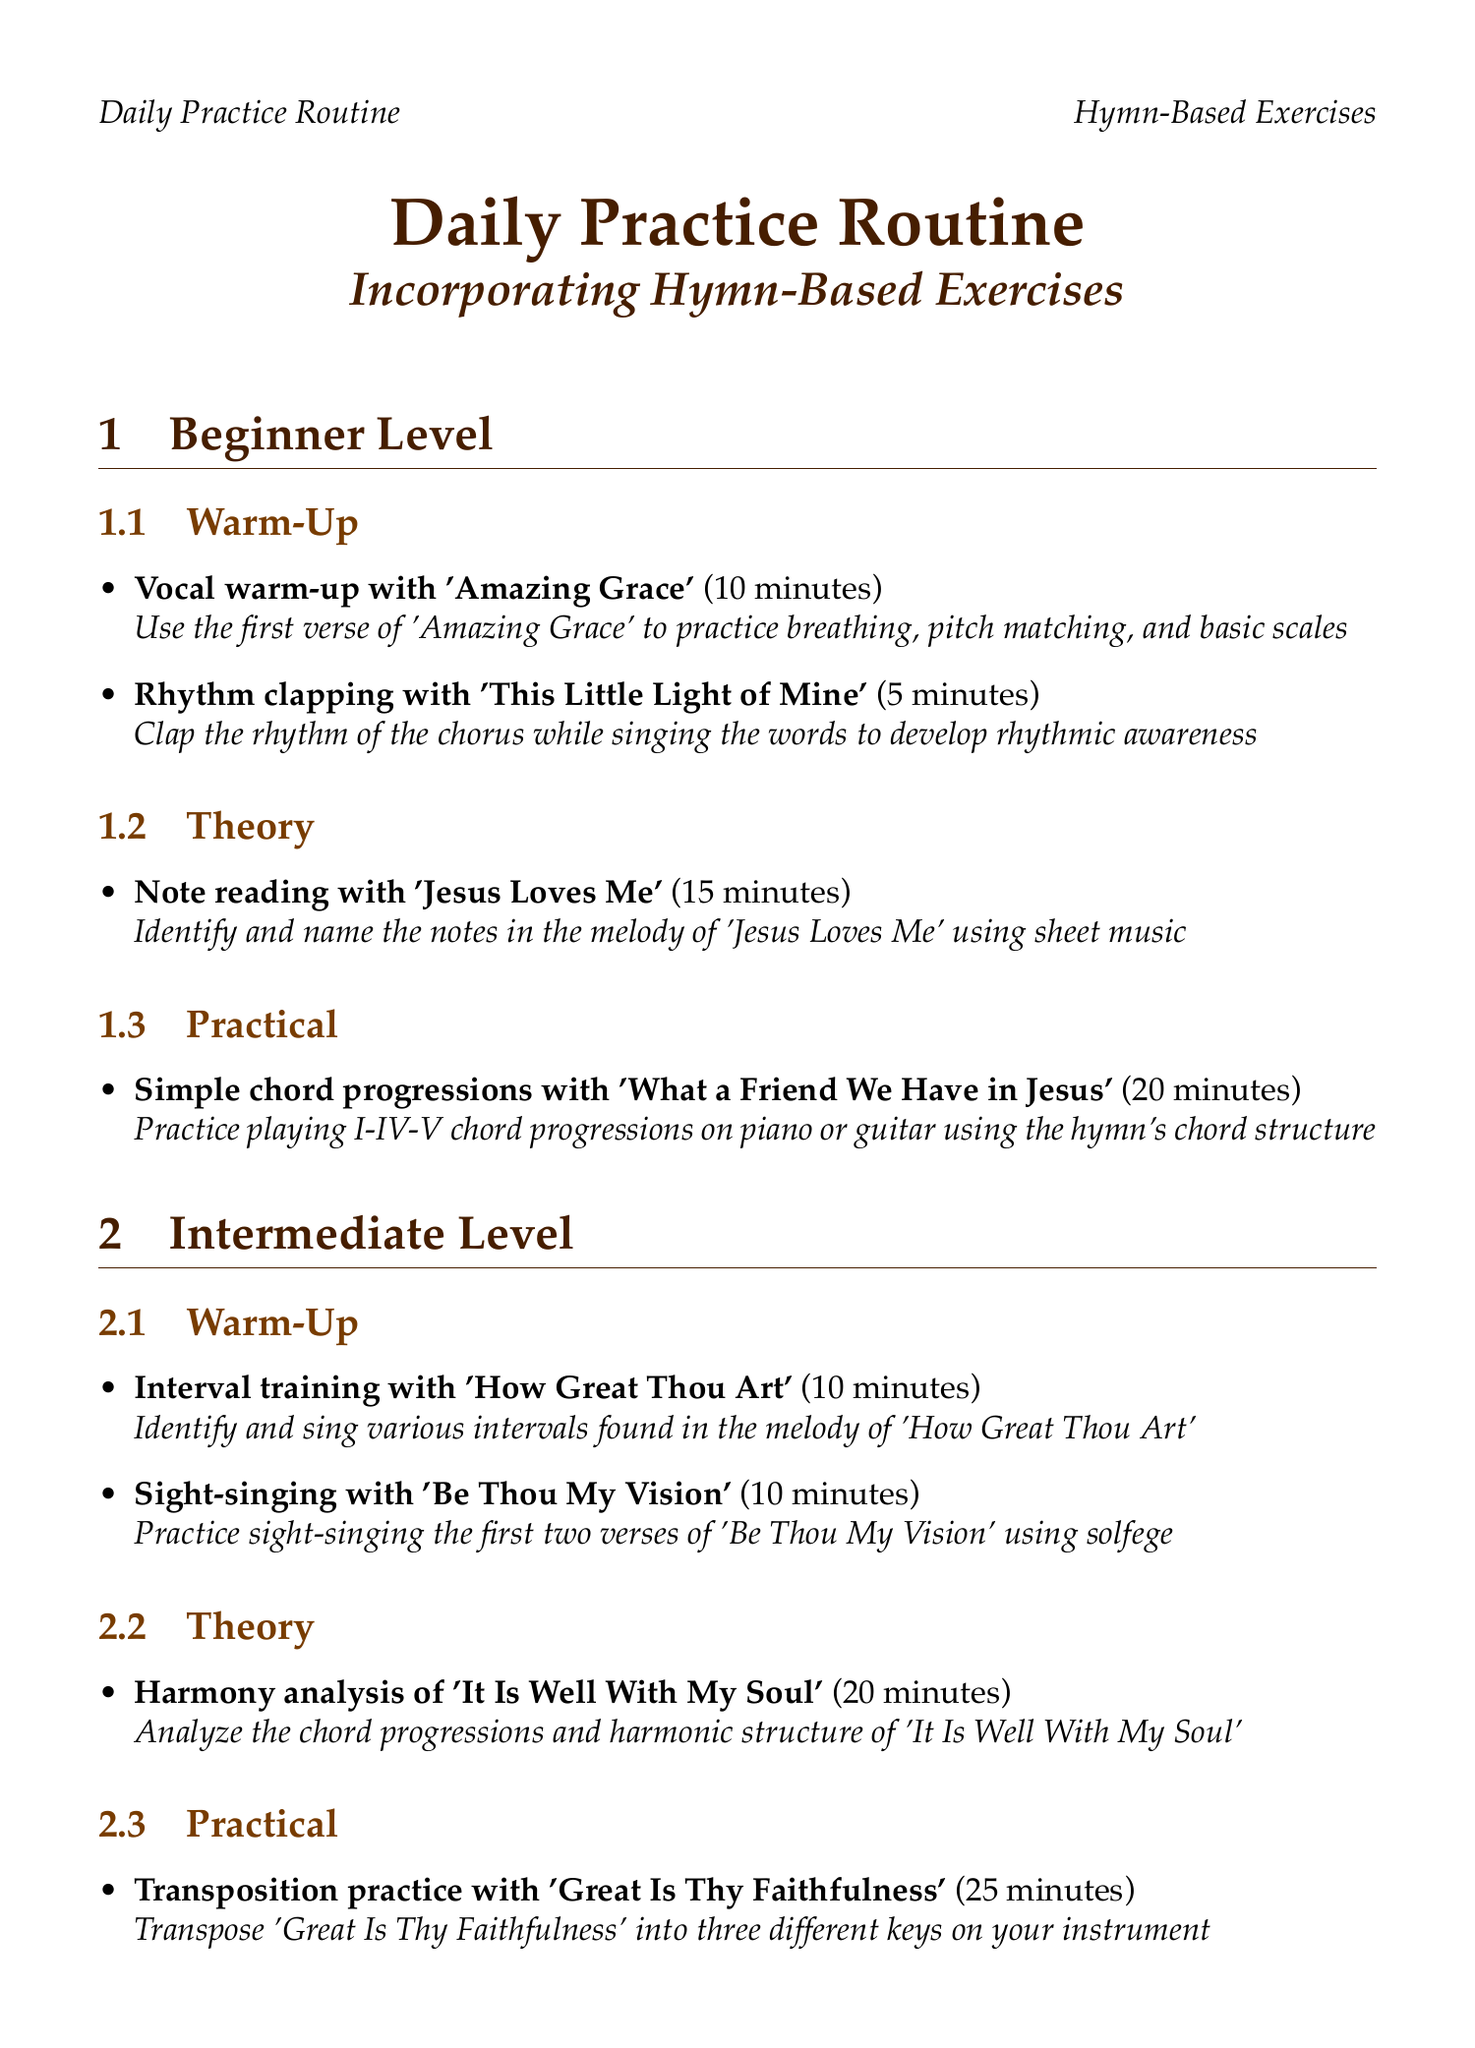what is the duration of the vocal warm-up for beginners? The vocal warm-up with 'Amazing Grace' lasts for 10 minutes.
Answer: 10 minutes which hymn is used for interval training in the intermediate level? Interval training uses the hymn 'How Great Thou Art'.
Answer: How Great Thou Art how long is the transposition practice for intermediates? The transposition practice with 'Great Is Thy Faithfulness' is 25 minutes long.
Answer: 25 minutes what type of exercises are included in the advanced warm-up? The advanced warm-up includes advanced vocal exercises.
Answer: advanced vocal exercises what is the main focus of the modulation study in the advanced level? The main focus is on analyzing and practicing the modulations in 'And Can It Be'.
Answer: analyzing and practicing modulations how many minutes are dedicated to harmonic analysis in the intermediate level? The harmony analysis of 'It Is Well With My Soul' is allocated 20 minutes.
Answer: 20 minutes which exercise is aimed at improvisation in the advanced level? The exercise for improvisation is based on 'When I Survey the Wondrous Cross'.
Answer: When I Survey the Wondrous Cross how many exercises are listed under beginner practical activities? There is one exercise listed under beginner practical activities.
Answer: one exercise which hymn is used for note reading in the beginner theory section? The hymn used for note reading is 'Jesus Loves Me'.
Answer: Jesus Loves Me 